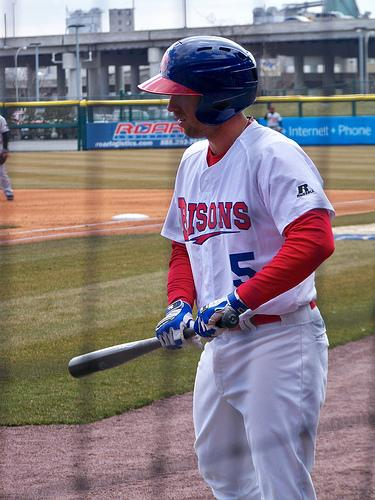What is the primary action taking place in the image? People are playing baseball in the image. Can you describe one of the objects near the batter's box? There is brown dirt near the batter's box. Identify the color and type of helmet the batter is wearing. The batter is wearing a blue and red helmet. What colors make up the batter's undershirt? The batter's undershirt is long-sleeved and red. What number and team does the batter belong to? The batter is number five and plays for the risons. What type of gloves is the batter wearing, and which colors are they? The batter is wearing blue, white, and black batting gloves. Provide a brief description of the batter's appearance. The batter is wearing a white, orange, and blue shirt, white pants, a red belt, blue and white batting gloves, and a blue and red helmet. Describe the features of the baseball field. The baseball field has brown dirt, green grass, and a yellow metal guard on top of the fence. Describe the building behind the baseball field. The building is a gray, two-level parking deck. Mention an advertisement in the image. There is a "roar" advertisement on the fence in the background. What type of building is behind the baseball field? Gray building Is the banner with the team's motto visible on the left side of the stadium? This instruction is misleading as there is no information about any banners or a stadium in the provided object list. The user will search in vain for these items. Does the batter have a long-sleeved undershirt? Yes, it is red Can you find the pink umbrella on the ground? It's next to the tree. There is no mention in the provided object list about a pink umbrella or a tree. This instruction is misleading as it asks the user to find non-existent objects. What color is the belt worn by the batter? Red Identify an object partially visible at X:201 Y:316. Part of a blue glove Describe the man's shirt color and pattern. White with orange and blue What number is the batter wearing on his jersey? Five What sport are the people in the image playing? Baseball What color is the pair of pants? White Is there any visible advertisement in the background? Yes, on the fence What is the type and color of the object at X:64 Y:320? Black baseball bat What kind of parking structure is in the background? Two-level parking deck Choose the correct color of the outfield grass: (a) green (b) brown (c) yellow (d) blue (a) green Spot the green ball flying in the air on the right side, above the fence. There is no mention of a green ball in the list of objects detected, so making the user look for it above the fence diverts their attention from the actual content of the image. Read the text on the object at X:172 Y:160. bisons baseball jersey List the colors of the batter's gloves. Blue, white, and black Identify the color and type of object at X:146 Y:295. Blue glove Describe the colors of the helmet worn by the man with the blue and red helmet. Blue and red Have you noticed the red car parked outside the gray building, right next to the entrance? Asking the user to find a red car and the entrance to a gray building is misleading since these elements are not present in the given list of objects. Such an instruction will misguide the viewer to identify objects that are not part of the image. Describe the type and color of the object at X:47 Y:325. Edge of a black bat Identify the cat sitting on the bench in the background, it is wearing a cute hat. In the given list of detected objects, there is no mention of a cat, a bench, or a hat. The user will be misled into looking for elements that are not part of the image. Observe the player with the yellow shoes running towards the goal. There are no indications of any players wearing yellow shoes or any goal in the object list. This instruction will make the user look for something irrelevant to the actual image content. What is the advertisement for in the background? ROAR Describe the baseball helmet that has partial information at X:204 Y:63. Part of a blue and red helmet 